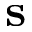Convert formula to latex. <formula><loc_0><loc_0><loc_500><loc_500>s</formula> 